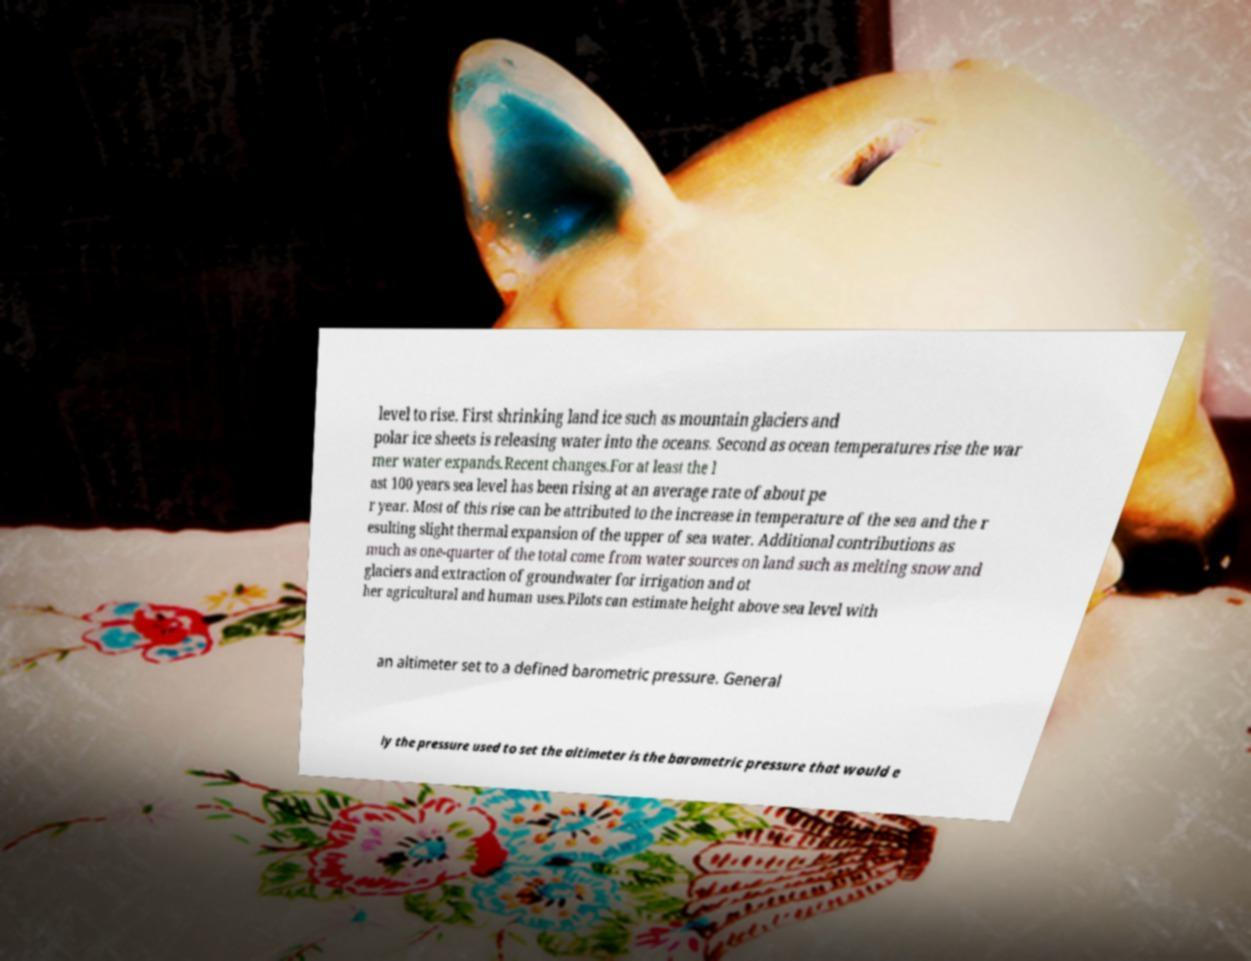Could you assist in decoding the text presented in this image and type it out clearly? level to rise. First shrinking land ice such as mountain glaciers and polar ice sheets is releasing water into the oceans. Second as ocean temperatures rise the war mer water expands.Recent changes.For at least the l ast 100 years sea level has been rising at an average rate of about pe r year. Most of this rise can be attributed to the increase in temperature of the sea and the r esulting slight thermal expansion of the upper of sea water. Additional contributions as much as one-quarter of the total come from water sources on land such as melting snow and glaciers and extraction of groundwater for irrigation and ot her agricultural and human uses.Pilots can estimate height above sea level with an altimeter set to a defined barometric pressure. General ly the pressure used to set the altimeter is the barometric pressure that would e 